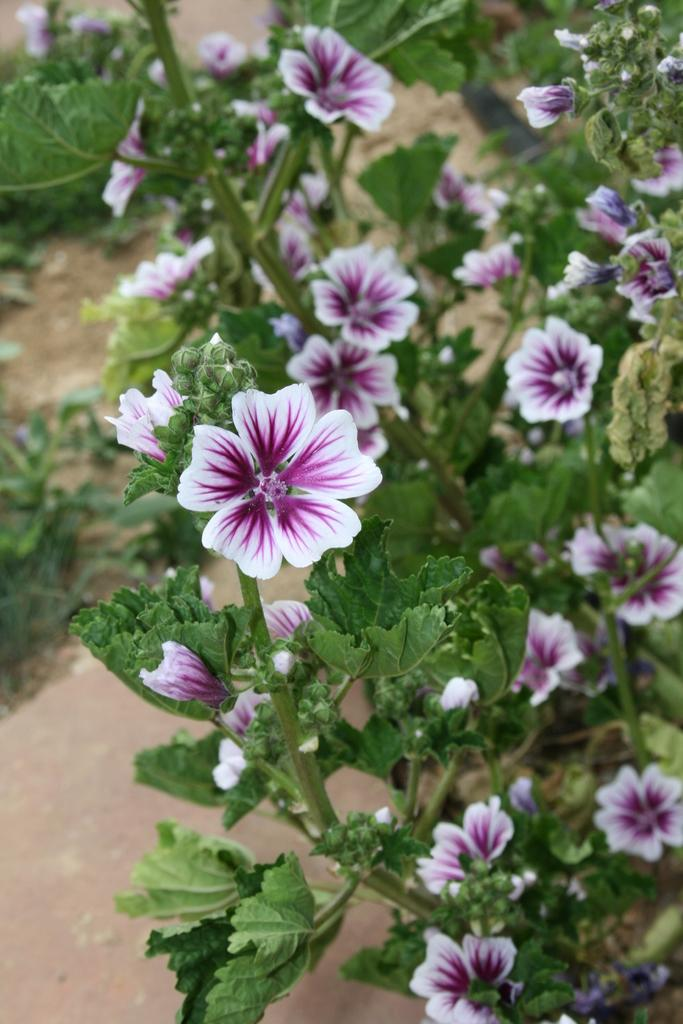What type of plant is in the image? The image contains a plant. What additional features can be seen on the plant? There are flowers on the plant. What is visible at the bottom of the image? Ground is visible towards the bottom of the image. What type of light is emitted by the plant in the image? The image does not show any light being emitted by the plant. Plants typically do not emit light. 